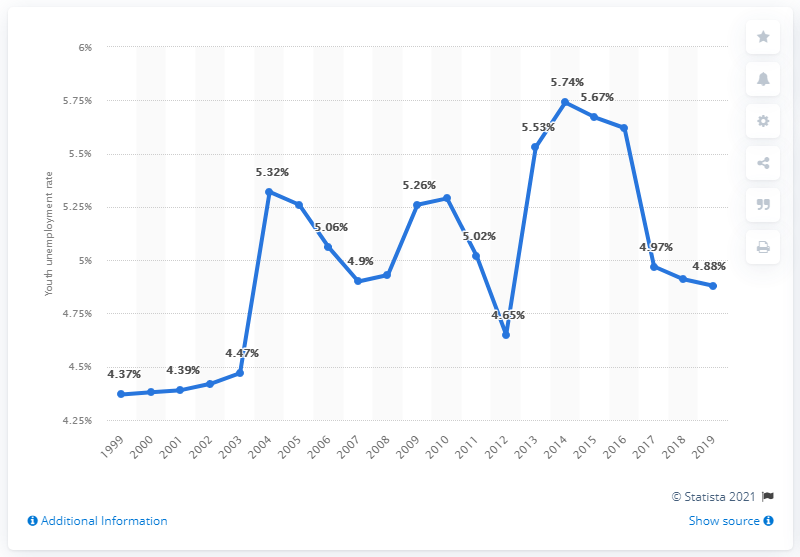Could you describe the trend of the youth unemployment rate in Guatemala over the past decade as shown in the image? Certainly! Over the past decade, the youth unemployment rate in Guatemala, as depicted in the chart, has shown fluctuations. It started above 5% in 2010, dipped slightly below that mark until it reached a low of around 4.9% in the mid-2010s, followed by a peak at 5.74% in 2017. Afterward, it decreased to 4.88% by 2019. Overall, the trend appears cyclical with minor ups and downs throughout the decade. 